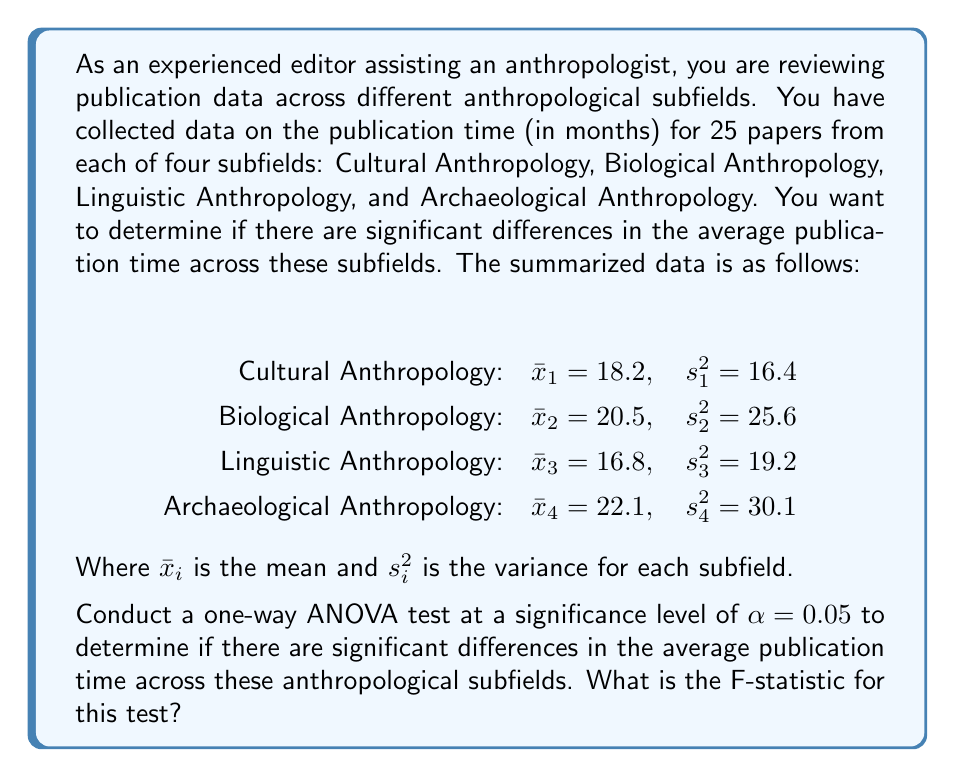Teach me how to tackle this problem. To conduct a one-way ANOVA test, we need to calculate the F-statistic. The steps are as follows:

1. Calculate the total sum of squares (SST):
   $$SST = \sum_{i=1}^{k} (n_i - 1)s_i^2 + \sum_{i=1}^{k} n_i(\bar{x}_i - \bar{x})^2$$
   Where $k$ is the number of groups (4 in this case), $n_i$ is the sample size for each group (25), and $\bar{x}$ is the grand mean.

2. Calculate the between-group sum of squares (SSB):
   $$SSB = \sum_{i=1}^{k} n_i(\bar{x}_i - \bar{x})^2$$

3. Calculate the within-group sum of squares (SSW):
   $$SSW = SST - SSB$$

4. Calculate the degrees of freedom:
   $$df_B = k - 1 = 4 - 1 = 3$$
   $$df_W = N - k = 100 - 4 = 96$$
   Where $N$ is the total sample size.

5. Calculate the mean square between (MSB) and mean square within (MSW):
   $$MSB = \frac{SSB}{df_B}$$
   $$MSW = \frac{SSW}{df_W}$$

6. Calculate the F-statistic:
   $$F = \frac{MSB}{MSW}$$

Let's perform these calculations:

First, calculate the grand mean:
$$\bar{x} = \frac{18.2 + 20.5 + 16.8 + 22.1}{4} = 19.4$$

Now, calculate SST:
$$SST = 24 \times (16.4 + 25.6 + 19.2 + 30.1) + 25 \times [(18.2 - 19.4)^2 + (20.5 - 19.4)^2 + (16.8 - 19.4)^2 + (22.1 - 19.4)^2]$$
$$SST = 2191.2 + 25 \times (1.44 + 1.21 + 6.76 + 7.29)$$
$$SST = 2191.2 + 417.5 = 2608.7$$

Calculate SSB:
$$SSB = 25 \times [(18.2 - 19.4)^2 + (20.5 - 19.4)^2 + (16.8 - 19.4)^2 + (22.1 - 19.4)^2]$$
$$SSB = 417.5$$

Calculate SSW:
$$SSW = SST - SSB = 2608.7 - 417.5 = 2191.2$$

Calculate MSB and MSW:
$$MSB = \frac{SSB}{df_B} = \frac{417.5}{3} = 139.17$$
$$MSW = \frac{SSW}{df_W} = \frac{2191.2}{96} = 22.83$$

Finally, calculate the F-statistic:
$$F = \frac{MSB}{MSW} = \frac{139.17}{22.83} = 6.10$$
Answer: The F-statistic for this one-way ANOVA test is 6.10. 